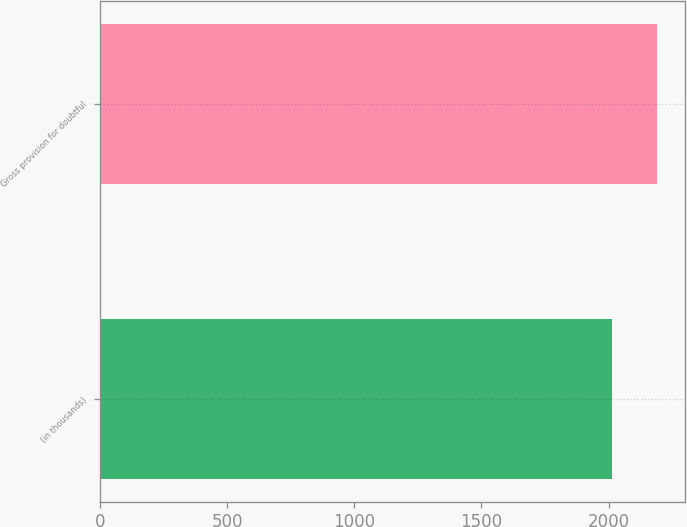<chart> <loc_0><loc_0><loc_500><loc_500><bar_chart><fcel>(in thousands)<fcel>Gross provision for doubtful<nl><fcel>2014<fcel>2192<nl></chart> 